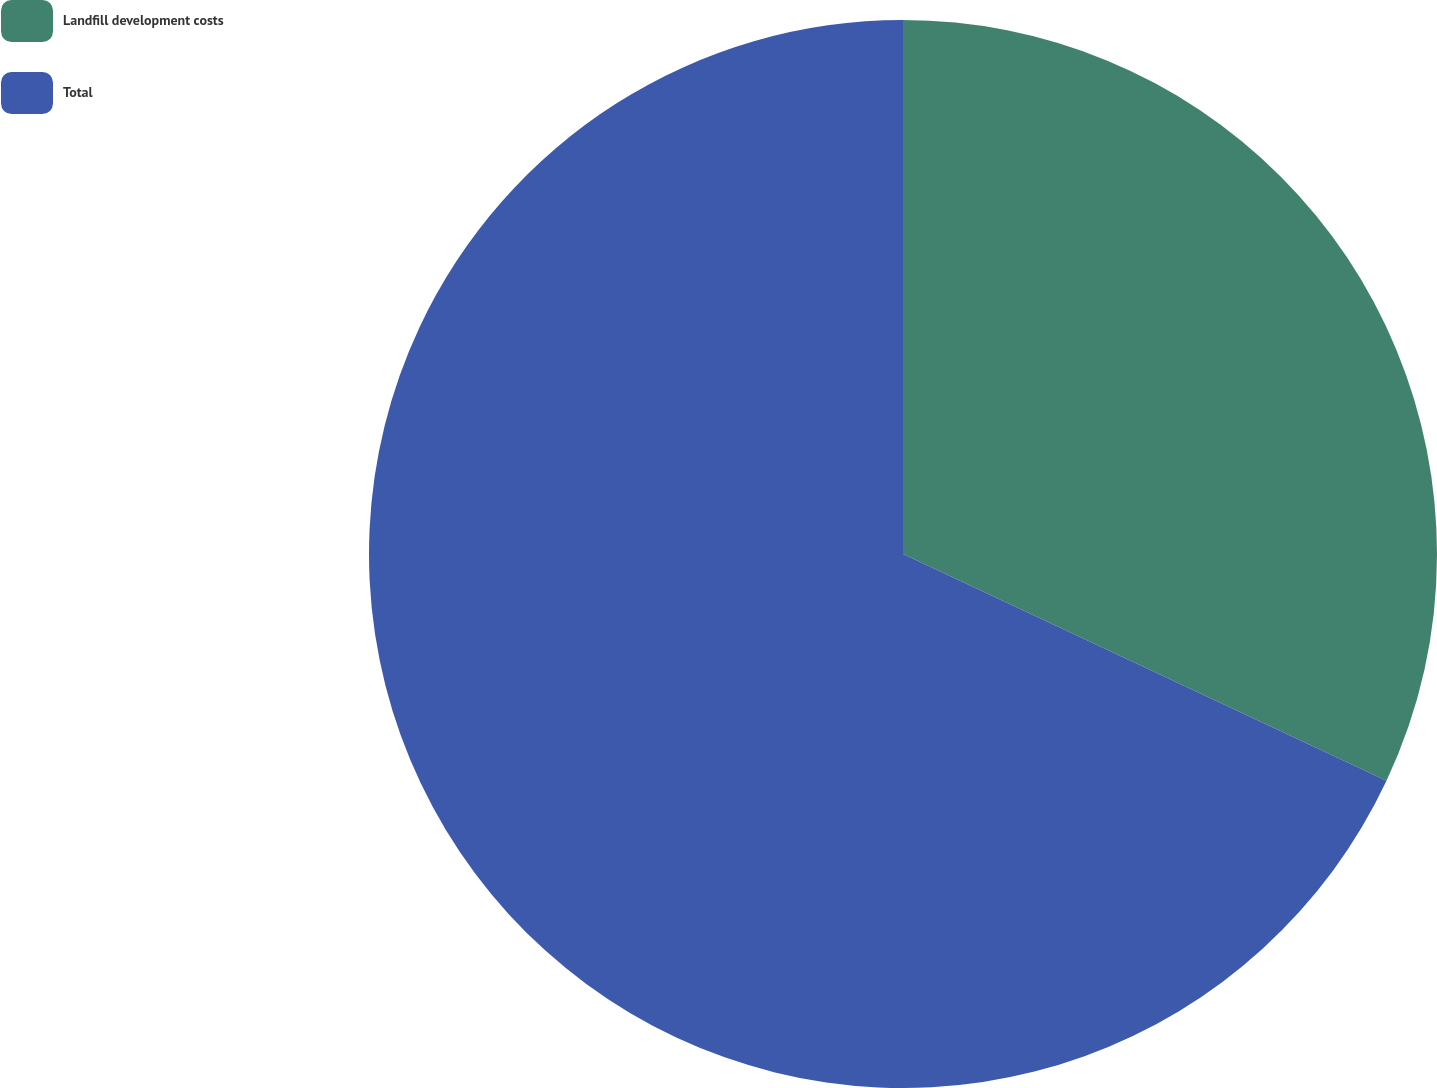Convert chart to OTSL. <chart><loc_0><loc_0><loc_500><loc_500><pie_chart><fcel>Landfill development costs<fcel>Total<nl><fcel>31.98%<fcel>68.02%<nl></chart> 